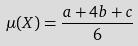<formula> <loc_0><loc_0><loc_500><loc_500>\mu ( X ) = \frac { a + 4 b + c } { 6 }</formula> 